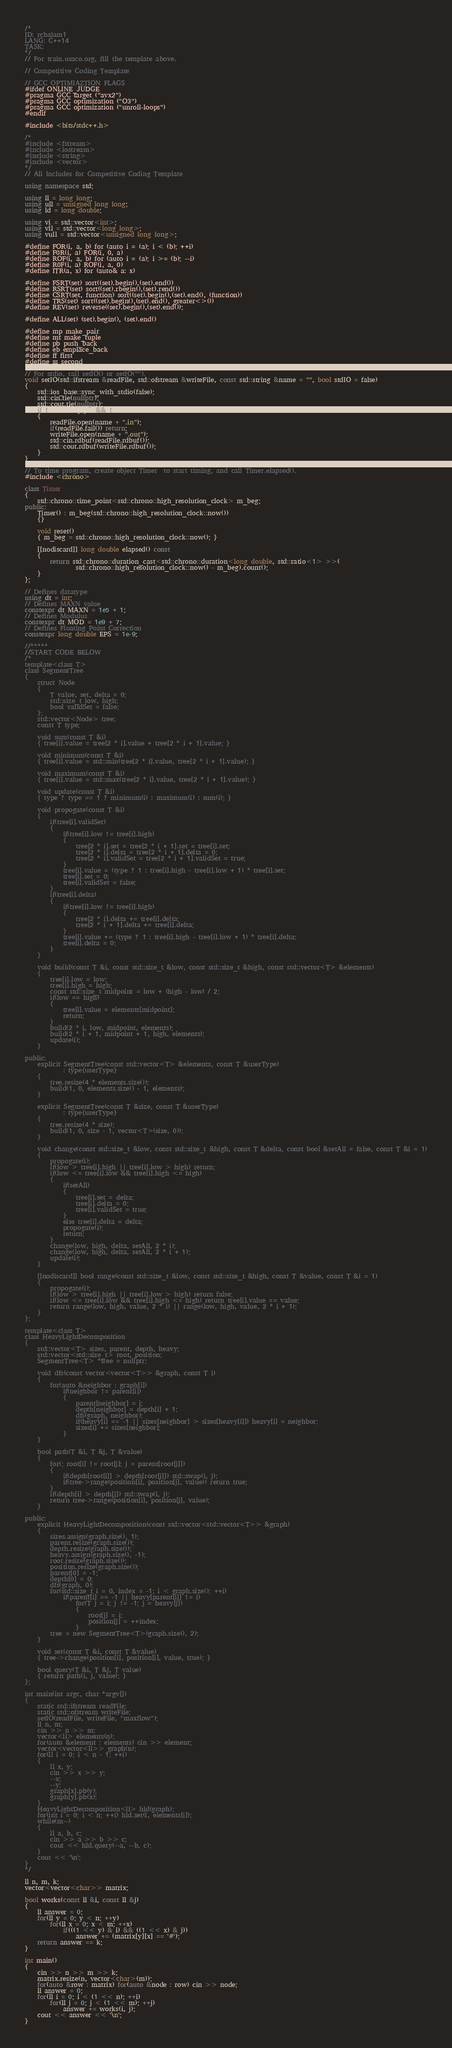<code> <loc_0><loc_0><loc_500><loc_500><_C++_>/*
ID: rchalam1
LANG: C++14
TASK:
*/
// For train.usaco.org, fill the template above.

// Competitive Coding Template

// GCC OPTIMIAZTION FLAGS
#ifdef ONLINE_JUDGE
#pragma GCC target ("avx2")
#pragma GCC optimization ("O3")
#pragma GCC optimization ("unroll-loops")
#endif

#include <bits/stdc++.h>

/*
#include <fstream>
#include <iostream>
#include <string>
#include <vector>
*/
// All Includes for Competitive Coding Template

using namespace std;

using ll = long long;
using ull = unsigned long long;
using ld = long double;

using vi = std::vector<int>;
using vll = std::vector<long long>;
using vull = std::vector<unsigned long long>;

#define FOR(i, a, b) for (auto i = (a); i < (b); ++i)
#define F0R(i, a) FOR(i, 0, a)
#define ROF(i, a, b) for (auto i = (a); i >= (b); --i)
#define R0F(i, a) ROF(i, a, 0)
#define ITR(a, x) for (auto& a: x)

#define FSRT(set) sort((set).begin(),(set).end())
#define RSRT(set) sort((set).rbegin(),(set).rend())
#define CSRT(set, function) sort((set).begin(),(set).end(), (function))
#define TRS(set) sort((set).begin(),(set).end(), greater<>())
#define REV(set) reverse((set).begin(),(set).end());

#define ALL(set) (set).begin(), (set).end()

#define mp make_pair
#define mt make_tuple
#define pb push_back
#define eb emplace_back
#define ff first
#define ss second

// For stdio, call setIO() or setIO("").
void setIO(std::ifstream &readFile, std::ofstream &writeFile, const std::string &name = "", bool stdIO = false)
{
	std::ios_base::sync_with_stdio(false);
	std::cin.tie(nullptr);
	std::cout.tie(nullptr);
	if(!name.empty() && !stdIO)
	{
		readFile.open(name + ".in");
		if(readFile.fail()) return;
		writeFile.open(name + ".out");
		std::cin.rdbuf(readFile.rdbuf());
		std::cout.rdbuf(writeFile.rdbuf());
	}
}

// To time program, create object Timer  to start timing, and call Timer.elapsed().
#include <chrono>

class Timer
{
	std::chrono::time_point<std::chrono::high_resolution_clock> m_beg;
public:
	Timer() : m_beg(std::chrono::high_resolution_clock::now())
	{}

	void reset()
	{ m_beg = std::chrono::high_resolution_clock::now(); }

	[[nodiscard]] long double elapsed() const
	{
		return std::chrono::duration_cast<std::chrono::duration<long double, std::ratio<1> >>(
				std::chrono::high_resolution_clock::now() - m_beg).count();
	}
};

// Defines datatype
using dt = int;
// Defines MAXN value
constexpr dt MAXN = 1e5 + 1;
// Defines Modulus
constexpr dt MOD = 1e9 + 7;
// Defines Floating Point Correction
constexpr long double EPS = 1e-9;

//*****
//START CODE BELOW
/*
template<class T>
class SegmentTree
{
	struct Node
	{
		T value, set, delta = 0;
		std::size_t low, high;
		bool validSet = false;
	};
	std::vector<Node> tree;
	const T type;

	void sum(const T &i)
	{ tree[i].value = tree[2 * i].value + tree[2 * i + 1].value; }

	void minimum(const T &i)
	{ tree[i].value = std::min(tree[2 * i].value, tree[2 * i + 1].value); }

	void maximum(const T &i)
	{ tree[i].value = std::max(tree[2 * i].value, tree[2 * i + 1].value); }

	void update(const T &i)
	{ type ? type == 1 ? minimum(i) : maximum(i) : sum(i); }

	void propogate(const T &i)
	{
		if(tree[i].validSet)
		{
			if(tree[i].low != tree[i].high)
			{
				tree[2 * i].set = tree[2 * i + 1].set = tree[i].set;
				tree[2 * i].delta = tree[2 * i + 1].delta = 0;
				tree[2 * i].validSet = tree[2 * i + 1].validSet = true;
			}
			tree[i].value = (type ? 1 : tree[i].high - tree[i].low + 1) * tree[i].set;
			tree[i].set = 0;
			tree[i].validSet = false;
		}
		if(tree[i].delta)
		{
			if(tree[i].low != tree[i].high)
			{
				tree[2 * i].delta += tree[i].delta;
				tree[2 * i + 1].delta += tree[i].delta;
			}
			tree[i].value += (type ? 1 : tree[i].high - tree[i].low + 1) * tree[i].delta;
			tree[i].delta = 0;
		}
	}

	void build(const T &i, const std::size_t &low, const std::size_t &high, const std::vector<T> &elements)
	{
		tree[i].low = low;
		tree[i].high = high;
		const std::size_t midpoint = low + (high - low) / 2;
		if(low == high)
		{
			tree[i].value = elements[midpoint];
			return;
		}
		build(2 * i, low, midpoint, elements);
		build(2 * i + 1, midpoint + 1, high, elements);
		update(i);
	}

public:
	explicit SegmentTree(const std::vector<T> &elements, const T &userType)
			: type{userType}
	{
		tree.resize(4 * elements.size());
		build(1, 0, elements.size() - 1, elements);
	}

	explicit SegmentTree(const T &size, const T &userType)
			: type{userType}
	{
		tree.resize(4 * size);
		build(1, 0, size - 1, vector<T>(size, 0));
	}

	void change(const std::size_t &low, const std::size_t &high, const T &delta, const bool &setAll = false, const T &i = 1)
	{
		propogate(i);
		if(low > tree[i].high || tree[i].low > high) return;
		if(low <= tree[i].low && tree[i].high <= high)
		{
			if(setAll)
			{
				tree[i].set = delta;
				tree[i].delta = 0;
				tree[i].validSet = true;
			}
			else tree[i].delta = delta;
			propogate(i);
			return;
		}
		change(low, high, delta, setAll, 2 * i);
		change(low, high, delta, setAll, 2 * i + 1);
		update(i);
	}

	[[nodiscard]] bool range(const std::size_t &low, const std::size_t &high, const T &value, const T &i = 1)
	{
		propogate(i);
		if(low > tree[i].high || tree[i].low > high) return false;
		if(low <= tree[i].low && tree[i].high <= high) return tree[i].value == value;
		return range(low, high, value, 2 * i) || range(low, high, value, 2 * i + 1);
	}
};

template<class T>
class HeavyLightDecomposition
{
	std::vector<T> sizes, parent, depth, heavy;
	std::vector<std::size_t> root, position;
	SegmentTree<T> *tree = nullptr;

	void dfs(const vector<vector<T>> &graph, const T i)
	{
		for(auto &neighbor : graph[i])
			if(neighbor != parent[i])
			{
				parent[neighbor] = i;
				depth[neighbor] = depth[i] + 1;
				dfs(graph, neighbor);
				if(heavy[i] == -1 || sizes[neighbor] > sizes[heavy[i]]) heavy[i] = neighbor;
				sizes[i] += sizes[neighbor];
			}
	}

	bool path(T &i, T &j, T &value)
	{
		for(; root[i] != root[j]; j = parent[root[j]])
		{
			if(depth[root[i]] > depth[root[j]]) std::swap(i, j);
			if(tree->range(position[i], position[j], value)) return true;
		}
		if(depth[i] > depth[j]) std::swap(i, j);
		return tree->range(position[i], position[j], value);
	}

public:
	explicit HeavyLightDecomposition(const std::vector<std::vector<T>> &graph)
	{
		sizes.assign(graph.size(), 1);
		parent.resize(graph.size());
		depth.resize(graph.size());
		heavy.assign(graph.size(), -1);
		root.resize(graph.size());
		position.resize(graph.size());
		parent[0] = -1;
		depth[0] = 0;
		dfs(graph, 0);
		for(std::size_t i = 0, index = -1; i < graph.size(); ++i)
			if(parent[i] == -1 || heavy[parent[i]] != i)
				for(T j = i; j != -1; j = heavy[j])
				{
					root[j] = i;
					position[j] = ++index;
				}
		tree = new SegmentTree<T>(graph.size(), 2);
	}

	void set(const T &i, const T &value)
	{ tree->change(position[i], position[i], value, true); }

	bool query(T &i, T &j, T value)
	{ return path(i, j, value); }
};

int main(int argc, char *argv[])
{
	static std::ifstream readFile;
	static std::ofstream writeFile;
	setIO(readFile, writeFile, "maxflow");
	ll n, m;
	cin >> n >> m;
	vector<ll> elements(n);
	for(auto &element : elements) cin >> element;
	vector<vector<ll>> graph(n);
	for(ll i = 0; i < n - 1; ++i)
	{
		ll x, y;
		cin >> x >> y;
		--x;
		--y;
		graph[x].pb(y);
		graph[y].pb(x);
	}
	HeavyLightDecomposition<ll> hld(graph);
	for(int i = 0; i < n; ++i) hld.set(i, elements[i]);
	while(m--)
	{
		ll a, b, c;
		cin >> a >> b >> c;
		cout << hld.query(--a, --b, c);
	}
	cout << '\n';
}
*/

ll n, m, k;
vector<vector<char>> matrix;

bool works(const ll &i, const ll &j)
{
	ll answer = 0;
	for(ll y = 0; y < n; ++y)
		for(ll x = 0; x < m; ++x)
			if(((1 << y) & i) && ((1 << x) & j))
				answer += (matrix[y][x] == '#');
	return answer == k;
}

int main()
{
	cin >> n >> m >> k;
	matrix.resize(n, vector<char>(m));
	for(auto &row : matrix) for(auto &node : row) cin >> node;
	ll answer = 0;
	for(ll i = 0; i < (1 << n); ++i)
		for(ll j = 0; j < (1 << m); ++j)
			answer += works(i, j);
	cout << answer << '\n';
}</code> 